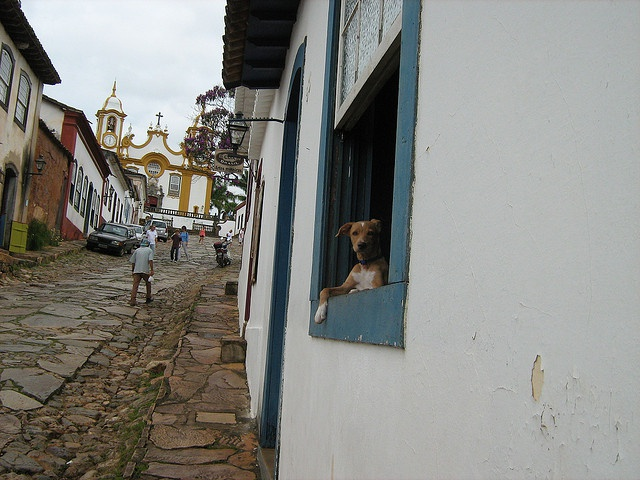Describe the objects in this image and their specific colors. I can see dog in black, maroon, and gray tones, people in black, gray, darkgray, and maroon tones, car in black, gray, and darkgray tones, motorcycle in black, gray, maroon, and darkgray tones, and car in black, gray, darkgray, and lightgray tones in this image. 